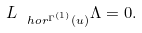<formula> <loc_0><loc_0><loc_500><loc_500>L _ { \ h o r ^ { \Gamma ^ { ( 1 ) } } ( u ) } \Lambda = 0 .</formula> 